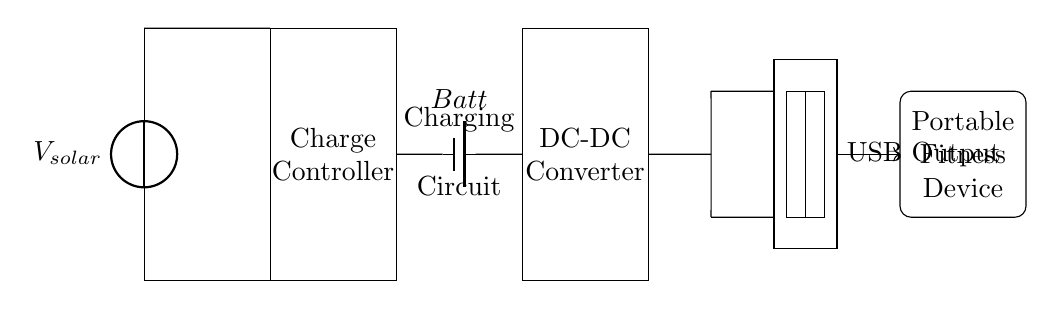What is the voltage source used in this circuit? The voltage source in this circuit is depicted as a solar panel, which is labeled as V_solar. It indicates the power supply origin for the charging circuit.
Answer: V solar What component is responsible for voltage regulation? The charge controller, located between the solar panel and the battery, ensures that the voltage supplied to the battery is suitable for charging. It prevents overcharging and prolongs battery life.
Answer: Charge Controller How many main components are there in this circuit? The circuit comprises four main components: the solar panel, the charge controller, the battery, and the DC-DC converter. Counting these elements gives the total number of components used for the charging process.
Answer: Four What is the output type of this circuit? The circuit is designed to provide a USB output, which is indicated as such in the diagram. This aligns with standard charging interfaces for portable devices, offering convenience to users.
Answer: USB Output What is the purpose of the DC-DC converter? The DC-DC converter takes the voltage from the battery and adjusts it to the required level for USB output, ensuring compatibility with the charging needs of the portable fitness device.
Answer: Voltage adjustment Which component stores energy in this circuit? The battery is the component responsible for storing energy, as it accumulates power generated from the solar panel through the charge controller, allowing power availability for the fitness device when needed.
Answer: Battery What is being charged in this circuit? The circuit is designed to charge a portable fitness device, which is indicated clearly in the diagram and represents the end-use application of the energy harnessed.
Answer: Portable Fitness Device 